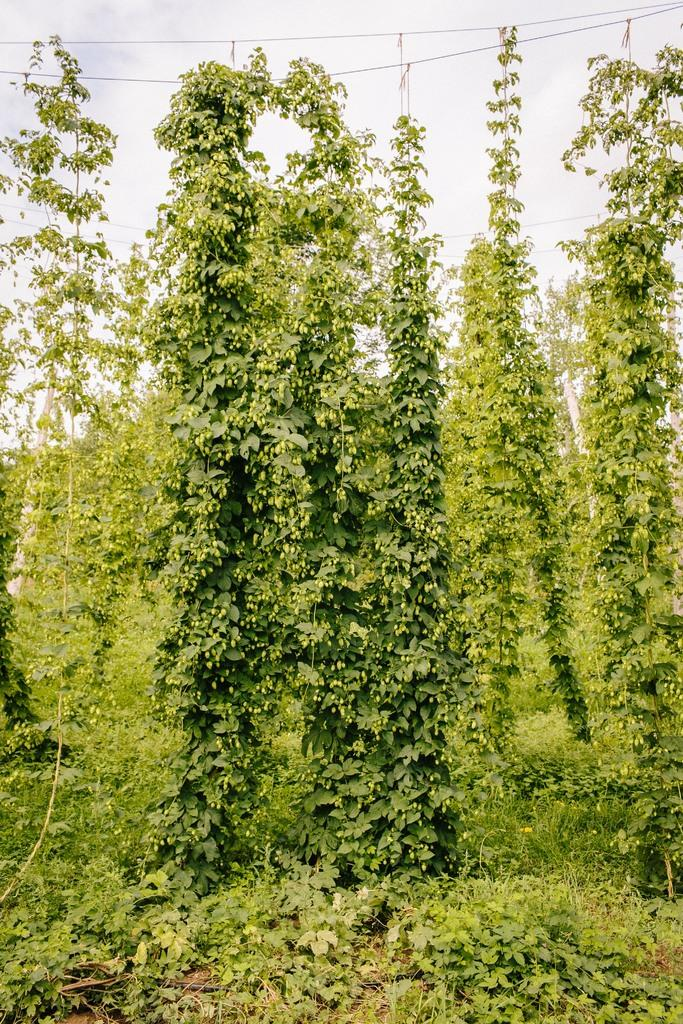What type of vegetation can be seen in the image? There are trees in the image. How many trees are visible in the image? The number of trees cannot be determined from the provided facts. What is the general setting of the image? The image features trees, which suggests a natural or outdoor setting. What type of disease is being treated by the mom in the image? There is no mom or disease present in the image; it only features trees. 